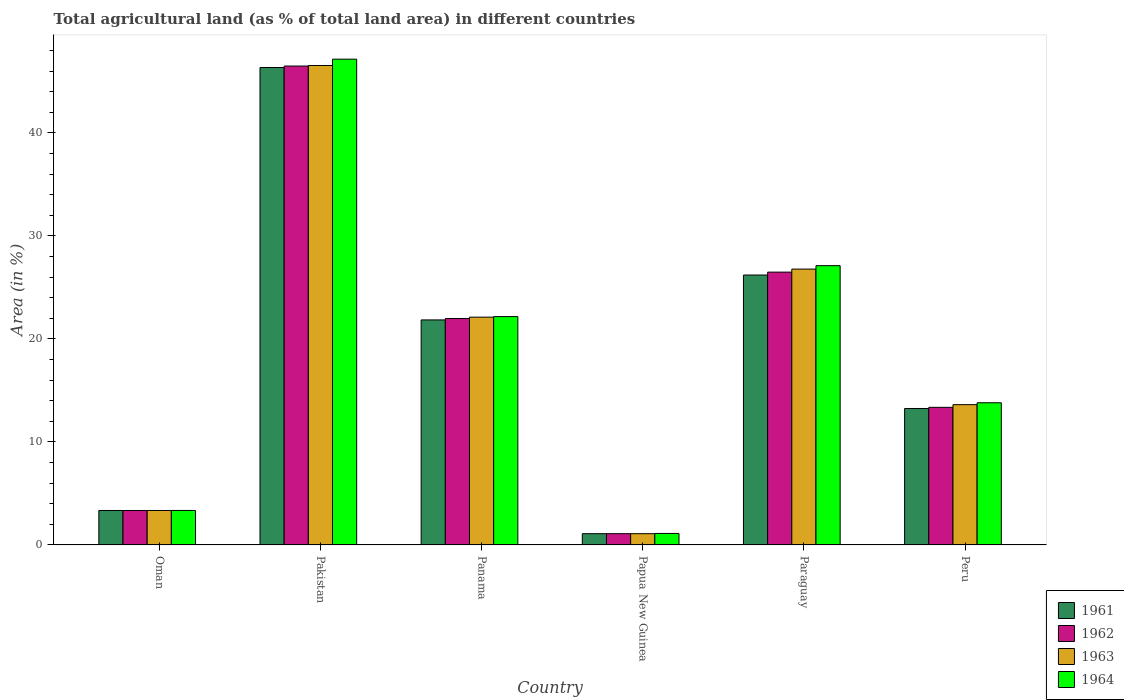How many groups of bars are there?
Offer a terse response. 6. How many bars are there on the 6th tick from the left?
Ensure brevity in your answer.  4. How many bars are there on the 2nd tick from the right?
Make the answer very short. 4. What is the label of the 2nd group of bars from the left?
Your answer should be very brief. Pakistan. In how many cases, is the number of bars for a given country not equal to the number of legend labels?
Your answer should be very brief. 0. What is the percentage of agricultural land in 1961 in Pakistan?
Your answer should be compact. 46.35. Across all countries, what is the maximum percentage of agricultural land in 1963?
Ensure brevity in your answer.  46.54. Across all countries, what is the minimum percentage of agricultural land in 1962?
Offer a very short reply. 1.09. In which country was the percentage of agricultural land in 1962 maximum?
Provide a short and direct response. Pakistan. In which country was the percentage of agricultural land in 1961 minimum?
Give a very brief answer. Papua New Guinea. What is the total percentage of agricultural land in 1961 in the graph?
Give a very brief answer. 112.08. What is the difference between the percentage of agricultural land in 1963 in Oman and that in Paraguay?
Ensure brevity in your answer.  -23.44. What is the difference between the percentage of agricultural land in 1961 in Peru and the percentage of agricultural land in 1962 in Paraguay?
Offer a terse response. -13.24. What is the average percentage of agricultural land in 1962 per country?
Keep it short and to the point. 18.79. What is the difference between the percentage of agricultural land of/in 1963 and percentage of agricultural land of/in 1962 in Oman?
Your answer should be compact. 0. In how many countries, is the percentage of agricultural land in 1963 greater than 30 %?
Your response must be concise. 1. What is the ratio of the percentage of agricultural land in 1961 in Pakistan to that in Paraguay?
Provide a succinct answer. 1.77. What is the difference between the highest and the second highest percentage of agricultural land in 1962?
Your answer should be very brief. 4.5. What is the difference between the highest and the lowest percentage of agricultural land in 1962?
Provide a succinct answer. 45.4. Is it the case that in every country, the sum of the percentage of agricultural land in 1963 and percentage of agricultural land in 1961 is greater than the sum of percentage of agricultural land in 1962 and percentage of agricultural land in 1964?
Provide a short and direct response. No. What does the 3rd bar from the right in Paraguay represents?
Ensure brevity in your answer.  1962. Is it the case that in every country, the sum of the percentage of agricultural land in 1963 and percentage of agricultural land in 1961 is greater than the percentage of agricultural land in 1962?
Your answer should be compact. Yes. How many bars are there?
Offer a very short reply. 24. Are the values on the major ticks of Y-axis written in scientific E-notation?
Your response must be concise. No. Does the graph contain grids?
Keep it short and to the point. No. What is the title of the graph?
Give a very brief answer. Total agricultural land (as % of total land area) in different countries. What is the label or title of the X-axis?
Ensure brevity in your answer.  Country. What is the label or title of the Y-axis?
Your answer should be compact. Area (in %). What is the Area (in %) in 1961 in Oman?
Keep it short and to the point. 3.34. What is the Area (in %) of 1962 in Oman?
Ensure brevity in your answer.  3.34. What is the Area (in %) of 1963 in Oman?
Your answer should be very brief. 3.34. What is the Area (in %) of 1964 in Oman?
Offer a terse response. 3.35. What is the Area (in %) of 1961 in Pakistan?
Give a very brief answer. 46.35. What is the Area (in %) in 1962 in Pakistan?
Give a very brief answer. 46.49. What is the Area (in %) in 1963 in Pakistan?
Your response must be concise. 46.54. What is the Area (in %) in 1964 in Pakistan?
Ensure brevity in your answer.  47.16. What is the Area (in %) of 1961 in Panama?
Your answer should be very brief. 21.85. What is the Area (in %) in 1962 in Panama?
Offer a terse response. 21.98. What is the Area (in %) in 1963 in Panama?
Your answer should be very brief. 22.11. What is the Area (in %) in 1964 in Panama?
Ensure brevity in your answer.  22.17. What is the Area (in %) in 1961 in Papua New Guinea?
Your response must be concise. 1.09. What is the Area (in %) of 1962 in Papua New Guinea?
Provide a succinct answer. 1.09. What is the Area (in %) in 1963 in Papua New Guinea?
Provide a succinct answer. 1.09. What is the Area (in %) in 1964 in Papua New Guinea?
Your response must be concise. 1.12. What is the Area (in %) in 1961 in Paraguay?
Offer a very short reply. 26.2. What is the Area (in %) in 1962 in Paraguay?
Give a very brief answer. 26.48. What is the Area (in %) of 1963 in Paraguay?
Provide a short and direct response. 26.78. What is the Area (in %) of 1964 in Paraguay?
Ensure brevity in your answer.  27.11. What is the Area (in %) of 1961 in Peru?
Your answer should be compact. 13.25. What is the Area (in %) in 1962 in Peru?
Keep it short and to the point. 13.36. What is the Area (in %) in 1963 in Peru?
Your answer should be very brief. 13.62. What is the Area (in %) of 1964 in Peru?
Offer a very short reply. 13.8. Across all countries, what is the maximum Area (in %) of 1961?
Provide a short and direct response. 46.35. Across all countries, what is the maximum Area (in %) of 1962?
Your response must be concise. 46.49. Across all countries, what is the maximum Area (in %) in 1963?
Your answer should be very brief. 46.54. Across all countries, what is the maximum Area (in %) of 1964?
Provide a short and direct response. 47.16. Across all countries, what is the minimum Area (in %) in 1961?
Ensure brevity in your answer.  1.09. Across all countries, what is the minimum Area (in %) in 1962?
Provide a succinct answer. 1.09. Across all countries, what is the minimum Area (in %) in 1963?
Your answer should be compact. 1.09. Across all countries, what is the minimum Area (in %) of 1964?
Offer a terse response. 1.12. What is the total Area (in %) in 1961 in the graph?
Offer a very short reply. 112.08. What is the total Area (in %) in 1962 in the graph?
Offer a terse response. 112.75. What is the total Area (in %) of 1963 in the graph?
Provide a short and direct response. 113.49. What is the total Area (in %) in 1964 in the graph?
Offer a very short reply. 114.71. What is the difference between the Area (in %) in 1961 in Oman and that in Pakistan?
Offer a terse response. -43.01. What is the difference between the Area (in %) of 1962 in Oman and that in Pakistan?
Your response must be concise. -43.15. What is the difference between the Area (in %) in 1963 in Oman and that in Pakistan?
Ensure brevity in your answer.  -43.2. What is the difference between the Area (in %) of 1964 in Oman and that in Pakistan?
Offer a terse response. -43.81. What is the difference between the Area (in %) of 1961 in Oman and that in Panama?
Keep it short and to the point. -18.5. What is the difference between the Area (in %) of 1962 in Oman and that in Panama?
Give a very brief answer. -18.64. What is the difference between the Area (in %) in 1963 in Oman and that in Panama?
Make the answer very short. -18.77. What is the difference between the Area (in %) in 1964 in Oman and that in Panama?
Offer a very short reply. -18.82. What is the difference between the Area (in %) of 1961 in Oman and that in Papua New Guinea?
Make the answer very short. 2.25. What is the difference between the Area (in %) in 1962 in Oman and that in Papua New Guinea?
Provide a succinct answer. 2.25. What is the difference between the Area (in %) of 1963 in Oman and that in Papua New Guinea?
Ensure brevity in your answer.  2.25. What is the difference between the Area (in %) of 1964 in Oman and that in Papua New Guinea?
Provide a succinct answer. 2.23. What is the difference between the Area (in %) of 1961 in Oman and that in Paraguay?
Keep it short and to the point. -22.86. What is the difference between the Area (in %) of 1962 in Oman and that in Paraguay?
Your answer should be compact. -23.14. What is the difference between the Area (in %) in 1963 in Oman and that in Paraguay?
Provide a short and direct response. -23.44. What is the difference between the Area (in %) in 1964 in Oman and that in Paraguay?
Offer a very short reply. -23.77. What is the difference between the Area (in %) of 1961 in Oman and that in Peru?
Your answer should be very brief. -9.9. What is the difference between the Area (in %) of 1962 in Oman and that in Peru?
Give a very brief answer. -10.01. What is the difference between the Area (in %) of 1963 in Oman and that in Peru?
Provide a succinct answer. -10.27. What is the difference between the Area (in %) of 1964 in Oman and that in Peru?
Give a very brief answer. -10.46. What is the difference between the Area (in %) in 1961 in Pakistan and that in Panama?
Ensure brevity in your answer.  24.5. What is the difference between the Area (in %) in 1962 in Pakistan and that in Panama?
Give a very brief answer. 24.51. What is the difference between the Area (in %) in 1963 in Pakistan and that in Panama?
Keep it short and to the point. 24.43. What is the difference between the Area (in %) of 1964 in Pakistan and that in Panama?
Your answer should be compact. 24.99. What is the difference between the Area (in %) in 1961 in Pakistan and that in Papua New Guinea?
Give a very brief answer. 45.26. What is the difference between the Area (in %) of 1962 in Pakistan and that in Papua New Guinea?
Ensure brevity in your answer.  45.4. What is the difference between the Area (in %) of 1963 in Pakistan and that in Papua New Guinea?
Your response must be concise. 45.45. What is the difference between the Area (in %) of 1964 in Pakistan and that in Papua New Guinea?
Your response must be concise. 46.05. What is the difference between the Area (in %) of 1961 in Pakistan and that in Paraguay?
Your answer should be very brief. 20.15. What is the difference between the Area (in %) in 1962 in Pakistan and that in Paraguay?
Provide a succinct answer. 20.01. What is the difference between the Area (in %) of 1963 in Pakistan and that in Paraguay?
Provide a succinct answer. 19.76. What is the difference between the Area (in %) of 1964 in Pakistan and that in Paraguay?
Provide a succinct answer. 20.05. What is the difference between the Area (in %) of 1961 in Pakistan and that in Peru?
Provide a succinct answer. 33.1. What is the difference between the Area (in %) of 1962 in Pakistan and that in Peru?
Give a very brief answer. 33.13. What is the difference between the Area (in %) in 1963 in Pakistan and that in Peru?
Your answer should be very brief. 32.93. What is the difference between the Area (in %) in 1964 in Pakistan and that in Peru?
Your answer should be very brief. 33.36. What is the difference between the Area (in %) of 1961 in Panama and that in Papua New Guinea?
Provide a succinct answer. 20.75. What is the difference between the Area (in %) in 1962 in Panama and that in Papua New Guinea?
Ensure brevity in your answer.  20.89. What is the difference between the Area (in %) of 1963 in Panama and that in Papua New Guinea?
Your answer should be compact. 21.02. What is the difference between the Area (in %) of 1964 in Panama and that in Papua New Guinea?
Give a very brief answer. 21.05. What is the difference between the Area (in %) in 1961 in Panama and that in Paraguay?
Ensure brevity in your answer.  -4.36. What is the difference between the Area (in %) in 1962 in Panama and that in Paraguay?
Make the answer very short. -4.5. What is the difference between the Area (in %) of 1963 in Panama and that in Paraguay?
Make the answer very short. -4.67. What is the difference between the Area (in %) of 1964 in Panama and that in Paraguay?
Provide a short and direct response. -4.94. What is the difference between the Area (in %) of 1961 in Panama and that in Peru?
Keep it short and to the point. 8.6. What is the difference between the Area (in %) of 1962 in Panama and that in Peru?
Ensure brevity in your answer.  8.62. What is the difference between the Area (in %) in 1963 in Panama and that in Peru?
Keep it short and to the point. 8.5. What is the difference between the Area (in %) of 1964 in Panama and that in Peru?
Your answer should be very brief. 8.37. What is the difference between the Area (in %) of 1961 in Papua New Guinea and that in Paraguay?
Keep it short and to the point. -25.11. What is the difference between the Area (in %) of 1962 in Papua New Guinea and that in Paraguay?
Ensure brevity in your answer.  -25.39. What is the difference between the Area (in %) in 1963 in Papua New Guinea and that in Paraguay?
Ensure brevity in your answer.  -25.69. What is the difference between the Area (in %) of 1964 in Papua New Guinea and that in Paraguay?
Provide a short and direct response. -26. What is the difference between the Area (in %) of 1961 in Papua New Guinea and that in Peru?
Ensure brevity in your answer.  -12.15. What is the difference between the Area (in %) in 1962 in Papua New Guinea and that in Peru?
Your answer should be very brief. -12.27. What is the difference between the Area (in %) of 1963 in Papua New Guinea and that in Peru?
Provide a succinct answer. -12.52. What is the difference between the Area (in %) in 1964 in Papua New Guinea and that in Peru?
Offer a terse response. -12.69. What is the difference between the Area (in %) in 1961 in Paraguay and that in Peru?
Keep it short and to the point. 12.96. What is the difference between the Area (in %) of 1962 in Paraguay and that in Peru?
Provide a succinct answer. 13.13. What is the difference between the Area (in %) in 1963 in Paraguay and that in Peru?
Offer a terse response. 13.16. What is the difference between the Area (in %) of 1964 in Paraguay and that in Peru?
Your answer should be compact. 13.31. What is the difference between the Area (in %) of 1961 in Oman and the Area (in %) of 1962 in Pakistan?
Keep it short and to the point. -43.15. What is the difference between the Area (in %) in 1961 in Oman and the Area (in %) in 1963 in Pakistan?
Keep it short and to the point. -43.2. What is the difference between the Area (in %) of 1961 in Oman and the Area (in %) of 1964 in Pakistan?
Provide a succinct answer. -43.82. What is the difference between the Area (in %) of 1962 in Oman and the Area (in %) of 1963 in Pakistan?
Offer a terse response. -43.2. What is the difference between the Area (in %) in 1962 in Oman and the Area (in %) in 1964 in Pakistan?
Ensure brevity in your answer.  -43.82. What is the difference between the Area (in %) of 1963 in Oman and the Area (in %) of 1964 in Pakistan?
Your answer should be compact. -43.82. What is the difference between the Area (in %) of 1961 in Oman and the Area (in %) of 1962 in Panama?
Offer a terse response. -18.64. What is the difference between the Area (in %) in 1961 in Oman and the Area (in %) in 1963 in Panama?
Your answer should be compact. -18.77. What is the difference between the Area (in %) of 1961 in Oman and the Area (in %) of 1964 in Panama?
Your answer should be compact. -18.82. What is the difference between the Area (in %) of 1962 in Oman and the Area (in %) of 1963 in Panama?
Provide a short and direct response. -18.77. What is the difference between the Area (in %) in 1962 in Oman and the Area (in %) in 1964 in Panama?
Make the answer very short. -18.82. What is the difference between the Area (in %) of 1963 in Oman and the Area (in %) of 1964 in Panama?
Give a very brief answer. -18.82. What is the difference between the Area (in %) of 1961 in Oman and the Area (in %) of 1962 in Papua New Guinea?
Offer a very short reply. 2.25. What is the difference between the Area (in %) of 1961 in Oman and the Area (in %) of 1963 in Papua New Guinea?
Offer a terse response. 2.25. What is the difference between the Area (in %) of 1961 in Oman and the Area (in %) of 1964 in Papua New Guinea?
Your answer should be compact. 2.23. What is the difference between the Area (in %) in 1962 in Oman and the Area (in %) in 1963 in Papua New Guinea?
Make the answer very short. 2.25. What is the difference between the Area (in %) of 1962 in Oman and the Area (in %) of 1964 in Papua New Guinea?
Provide a succinct answer. 2.23. What is the difference between the Area (in %) of 1963 in Oman and the Area (in %) of 1964 in Papua New Guinea?
Ensure brevity in your answer.  2.23. What is the difference between the Area (in %) in 1961 in Oman and the Area (in %) in 1962 in Paraguay?
Your answer should be very brief. -23.14. What is the difference between the Area (in %) in 1961 in Oman and the Area (in %) in 1963 in Paraguay?
Ensure brevity in your answer.  -23.44. What is the difference between the Area (in %) of 1961 in Oman and the Area (in %) of 1964 in Paraguay?
Offer a terse response. -23.77. What is the difference between the Area (in %) of 1962 in Oman and the Area (in %) of 1963 in Paraguay?
Provide a succinct answer. -23.44. What is the difference between the Area (in %) of 1962 in Oman and the Area (in %) of 1964 in Paraguay?
Provide a succinct answer. -23.77. What is the difference between the Area (in %) in 1963 in Oman and the Area (in %) in 1964 in Paraguay?
Your answer should be very brief. -23.77. What is the difference between the Area (in %) of 1961 in Oman and the Area (in %) of 1962 in Peru?
Offer a terse response. -10.01. What is the difference between the Area (in %) in 1961 in Oman and the Area (in %) in 1963 in Peru?
Offer a very short reply. -10.27. What is the difference between the Area (in %) of 1961 in Oman and the Area (in %) of 1964 in Peru?
Make the answer very short. -10.46. What is the difference between the Area (in %) in 1962 in Oman and the Area (in %) in 1963 in Peru?
Ensure brevity in your answer.  -10.27. What is the difference between the Area (in %) in 1962 in Oman and the Area (in %) in 1964 in Peru?
Ensure brevity in your answer.  -10.46. What is the difference between the Area (in %) in 1963 in Oman and the Area (in %) in 1964 in Peru?
Provide a succinct answer. -10.46. What is the difference between the Area (in %) in 1961 in Pakistan and the Area (in %) in 1962 in Panama?
Make the answer very short. 24.37. What is the difference between the Area (in %) of 1961 in Pakistan and the Area (in %) of 1963 in Panama?
Your response must be concise. 24.23. What is the difference between the Area (in %) of 1961 in Pakistan and the Area (in %) of 1964 in Panama?
Offer a very short reply. 24.18. What is the difference between the Area (in %) of 1962 in Pakistan and the Area (in %) of 1963 in Panama?
Make the answer very short. 24.38. What is the difference between the Area (in %) of 1962 in Pakistan and the Area (in %) of 1964 in Panama?
Make the answer very short. 24.32. What is the difference between the Area (in %) of 1963 in Pakistan and the Area (in %) of 1964 in Panama?
Provide a succinct answer. 24.38. What is the difference between the Area (in %) in 1961 in Pakistan and the Area (in %) in 1962 in Papua New Guinea?
Offer a terse response. 45.26. What is the difference between the Area (in %) in 1961 in Pakistan and the Area (in %) in 1963 in Papua New Guinea?
Provide a succinct answer. 45.26. What is the difference between the Area (in %) of 1961 in Pakistan and the Area (in %) of 1964 in Papua New Guinea?
Your response must be concise. 45.23. What is the difference between the Area (in %) of 1962 in Pakistan and the Area (in %) of 1963 in Papua New Guinea?
Offer a very short reply. 45.4. What is the difference between the Area (in %) in 1962 in Pakistan and the Area (in %) in 1964 in Papua New Guinea?
Provide a succinct answer. 45.38. What is the difference between the Area (in %) of 1963 in Pakistan and the Area (in %) of 1964 in Papua New Guinea?
Your response must be concise. 45.43. What is the difference between the Area (in %) of 1961 in Pakistan and the Area (in %) of 1962 in Paraguay?
Make the answer very short. 19.87. What is the difference between the Area (in %) in 1961 in Pakistan and the Area (in %) in 1963 in Paraguay?
Your response must be concise. 19.57. What is the difference between the Area (in %) of 1961 in Pakistan and the Area (in %) of 1964 in Paraguay?
Your response must be concise. 19.24. What is the difference between the Area (in %) in 1962 in Pakistan and the Area (in %) in 1963 in Paraguay?
Offer a very short reply. 19.71. What is the difference between the Area (in %) in 1962 in Pakistan and the Area (in %) in 1964 in Paraguay?
Your answer should be very brief. 19.38. What is the difference between the Area (in %) of 1963 in Pakistan and the Area (in %) of 1964 in Paraguay?
Make the answer very short. 19.43. What is the difference between the Area (in %) of 1961 in Pakistan and the Area (in %) of 1962 in Peru?
Provide a short and direct response. 32.99. What is the difference between the Area (in %) in 1961 in Pakistan and the Area (in %) in 1963 in Peru?
Provide a succinct answer. 32.73. What is the difference between the Area (in %) in 1961 in Pakistan and the Area (in %) in 1964 in Peru?
Give a very brief answer. 32.55. What is the difference between the Area (in %) of 1962 in Pakistan and the Area (in %) of 1963 in Peru?
Keep it short and to the point. 32.88. What is the difference between the Area (in %) of 1962 in Pakistan and the Area (in %) of 1964 in Peru?
Provide a short and direct response. 32.69. What is the difference between the Area (in %) of 1963 in Pakistan and the Area (in %) of 1964 in Peru?
Ensure brevity in your answer.  32.74. What is the difference between the Area (in %) of 1961 in Panama and the Area (in %) of 1962 in Papua New Guinea?
Provide a succinct answer. 20.75. What is the difference between the Area (in %) of 1961 in Panama and the Area (in %) of 1963 in Papua New Guinea?
Make the answer very short. 20.75. What is the difference between the Area (in %) in 1961 in Panama and the Area (in %) in 1964 in Papua New Guinea?
Your answer should be very brief. 20.73. What is the difference between the Area (in %) of 1962 in Panama and the Area (in %) of 1963 in Papua New Guinea?
Keep it short and to the point. 20.89. What is the difference between the Area (in %) of 1962 in Panama and the Area (in %) of 1964 in Papua New Guinea?
Offer a very short reply. 20.86. What is the difference between the Area (in %) in 1963 in Panama and the Area (in %) in 1964 in Papua New Guinea?
Keep it short and to the point. 21. What is the difference between the Area (in %) of 1961 in Panama and the Area (in %) of 1962 in Paraguay?
Your answer should be compact. -4.64. What is the difference between the Area (in %) in 1961 in Panama and the Area (in %) in 1963 in Paraguay?
Make the answer very short. -4.94. What is the difference between the Area (in %) in 1961 in Panama and the Area (in %) in 1964 in Paraguay?
Provide a succinct answer. -5.27. What is the difference between the Area (in %) of 1962 in Panama and the Area (in %) of 1963 in Paraguay?
Your answer should be very brief. -4.8. What is the difference between the Area (in %) of 1962 in Panama and the Area (in %) of 1964 in Paraguay?
Provide a short and direct response. -5.13. What is the difference between the Area (in %) of 1963 in Panama and the Area (in %) of 1964 in Paraguay?
Make the answer very short. -5. What is the difference between the Area (in %) in 1961 in Panama and the Area (in %) in 1962 in Peru?
Ensure brevity in your answer.  8.49. What is the difference between the Area (in %) of 1961 in Panama and the Area (in %) of 1963 in Peru?
Offer a very short reply. 8.23. What is the difference between the Area (in %) of 1961 in Panama and the Area (in %) of 1964 in Peru?
Ensure brevity in your answer.  8.04. What is the difference between the Area (in %) in 1962 in Panama and the Area (in %) in 1963 in Peru?
Offer a terse response. 8.36. What is the difference between the Area (in %) of 1962 in Panama and the Area (in %) of 1964 in Peru?
Keep it short and to the point. 8.18. What is the difference between the Area (in %) of 1963 in Panama and the Area (in %) of 1964 in Peru?
Your answer should be very brief. 8.31. What is the difference between the Area (in %) of 1961 in Papua New Guinea and the Area (in %) of 1962 in Paraguay?
Give a very brief answer. -25.39. What is the difference between the Area (in %) of 1961 in Papua New Guinea and the Area (in %) of 1963 in Paraguay?
Provide a succinct answer. -25.69. What is the difference between the Area (in %) of 1961 in Papua New Guinea and the Area (in %) of 1964 in Paraguay?
Ensure brevity in your answer.  -26.02. What is the difference between the Area (in %) in 1962 in Papua New Guinea and the Area (in %) in 1963 in Paraguay?
Keep it short and to the point. -25.69. What is the difference between the Area (in %) in 1962 in Papua New Guinea and the Area (in %) in 1964 in Paraguay?
Your answer should be very brief. -26.02. What is the difference between the Area (in %) in 1963 in Papua New Guinea and the Area (in %) in 1964 in Paraguay?
Provide a succinct answer. -26.02. What is the difference between the Area (in %) in 1961 in Papua New Guinea and the Area (in %) in 1962 in Peru?
Your answer should be compact. -12.27. What is the difference between the Area (in %) of 1961 in Papua New Guinea and the Area (in %) of 1963 in Peru?
Your answer should be very brief. -12.52. What is the difference between the Area (in %) in 1961 in Papua New Guinea and the Area (in %) in 1964 in Peru?
Your response must be concise. -12.71. What is the difference between the Area (in %) in 1962 in Papua New Guinea and the Area (in %) in 1963 in Peru?
Make the answer very short. -12.52. What is the difference between the Area (in %) of 1962 in Papua New Guinea and the Area (in %) of 1964 in Peru?
Offer a terse response. -12.71. What is the difference between the Area (in %) of 1963 in Papua New Guinea and the Area (in %) of 1964 in Peru?
Keep it short and to the point. -12.71. What is the difference between the Area (in %) of 1961 in Paraguay and the Area (in %) of 1962 in Peru?
Ensure brevity in your answer.  12.85. What is the difference between the Area (in %) of 1961 in Paraguay and the Area (in %) of 1963 in Peru?
Ensure brevity in your answer.  12.59. What is the difference between the Area (in %) in 1961 in Paraguay and the Area (in %) in 1964 in Peru?
Offer a very short reply. 12.4. What is the difference between the Area (in %) in 1962 in Paraguay and the Area (in %) in 1963 in Peru?
Keep it short and to the point. 12.87. What is the difference between the Area (in %) of 1962 in Paraguay and the Area (in %) of 1964 in Peru?
Provide a short and direct response. 12.68. What is the difference between the Area (in %) in 1963 in Paraguay and the Area (in %) in 1964 in Peru?
Give a very brief answer. 12.98. What is the average Area (in %) of 1961 per country?
Make the answer very short. 18.68. What is the average Area (in %) in 1962 per country?
Provide a succinct answer. 18.79. What is the average Area (in %) of 1963 per country?
Keep it short and to the point. 18.92. What is the average Area (in %) of 1964 per country?
Make the answer very short. 19.12. What is the difference between the Area (in %) of 1961 and Area (in %) of 1963 in Oman?
Your answer should be very brief. 0. What is the difference between the Area (in %) in 1961 and Area (in %) in 1964 in Oman?
Your answer should be compact. -0. What is the difference between the Area (in %) of 1962 and Area (in %) of 1963 in Oman?
Ensure brevity in your answer.  0. What is the difference between the Area (in %) in 1962 and Area (in %) in 1964 in Oman?
Ensure brevity in your answer.  -0. What is the difference between the Area (in %) of 1963 and Area (in %) of 1964 in Oman?
Give a very brief answer. -0. What is the difference between the Area (in %) of 1961 and Area (in %) of 1962 in Pakistan?
Your answer should be very brief. -0.14. What is the difference between the Area (in %) of 1961 and Area (in %) of 1963 in Pakistan?
Offer a terse response. -0.19. What is the difference between the Area (in %) of 1961 and Area (in %) of 1964 in Pakistan?
Your response must be concise. -0.81. What is the difference between the Area (in %) of 1962 and Area (in %) of 1963 in Pakistan?
Make the answer very short. -0.05. What is the difference between the Area (in %) in 1962 and Area (in %) in 1964 in Pakistan?
Ensure brevity in your answer.  -0.67. What is the difference between the Area (in %) in 1963 and Area (in %) in 1964 in Pakistan?
Ensure brevity in your answer.  -0.62. What is the difference between the Area (in %) of 1961 and Area (in %) of 1962 in Panama?
Make the answer very short. -0.13. What is the difference between the Area (in %) in 1961 and Area (in %) in 1963 in Panama?
Offer a very short reply. -0.27. What is the difference between the Area (in %) in 1961 and Area (in %) in 1964 in Panama?
Make the answer very short. -0.32. What is the difference between the Area (in %) in 1962 and Area (in %) in 1963 in Panama?
Keep it short and to the point. -0.13. What is the difference between the Area (in %) in 1962 and Area (in %) in 1964 in Panama?
Ensure brevity in your answer.  -0.19. What is the difference between the Area (in %) in 1963 and Area (in %) in 1964 in Panama?
Give a very brief answer. -0.05. What is the difference between the Area (in %) in 1961 and Area (in %) in 1963 in Papua New Guinea?
Keep it short and to the point. 0. What is the difference between the Area (in %) in 1961 and Area (in %) in 1964 in Papua New Guinea?
Provide a succinct answer. -0.02. What is the difference between the Area (in %) of 1962 and Area (in %) of 1963 in Papua New Guinea?
Keep it short and to the point. 0. What is the difference between the Area (in %) of 1962 and Area (in %) of 1964 in Papua New Guinea?
Your answer should be compact. -0.02. What is the difference between the Area (in %) of 1963 and Area (in %) of 1964 in Papua New Guinea?
Make the answer very short. -0.02. What is the difference between the Area (in %) of 1961 and Area (in %) of 1962 in Paraguay?
Give a very brief answer. -0.28. What is the difference between the Area (in %) in 1961 and Area (in %) in 1963 in Paraguay?
Provide a short and direct response. -0.58. What is the difference between the Area (in %) of 1961 and Area (in %) of 1964 in Paraguay?
Make the answer very short. -0.91. What is the difference between the Area (in %) of 1962 and Area (in %) of 1963 in Paraguay?
Your answer should be compact. -0.3. What is the difference between the Area (in %) of 1962 and Area (in %) of 1964 in Paraguay?
Make the answer very short. -0.63. What is the difference between the Area (in %) of 1963 and Area (in %) of 1964 in Paraguay?
Your answer should be compact. -0.33. What is the difference between the Area (in %) of 1961 and Area (in %) of 1962 in Peru?
Keep it short and to the point. -0.11. What is the difference between the Area (in %) of 1961 and Area (in %) of 1963 in Peru?
Ensure brevity in your answer.  -0.37. What is the difference between the Area (in %) of 1961 and Area (in %) of 1964 in Peru?
Make the answer very short. -0.56. What is the difference between the Area (in %) in 1962 and Area (in %) in 1963 in Peru?
Keep it short and to the point. -0.26. What is the difference between the Area (in %) in 1962 and Area (in %) in 1964 in Peru?
Make the answer very short. -0.44. What is the difference between the Area (in %) of 1963 and Area (in %) of 1964 in Peru?
Offer a very short reply. -0.19. What is the ratio of the Area (in %) in 1961 in Oman to that in Pakistan?
Provide a short and direct response. 0.07. What is the ratio of the Area (in %) in 1962 in Oman to that in Pakistan?
Provide a short and direct response. 0.07. What is the ratio of the Area (in %) in 1963 in Oman to that in Pakistan?
Your answer should be compact. 0.07. What is the ratio of the Area (in %) in 1964 in Oman to that in Pakistan?
Provide a short and direct response. 0.07. What is the ratio of the Area (in %) of 1961 in Oman to that in Panama?
Your answer should be very brief. 0.15. What is the ratio of the Area (in %) of 1962 in Oman to that in Panama?
Offer a terse response. 0.15. What is the ratio of the Area (in %) of 1963 in Oman to that in Panama?
Ensure brevity in your answer.  0.15. What is the ratio of the Area (in %) in 1964 in Oman to that in Panama?
Keep it short and to the point. 0.15. What is the ratio of the Area (in %) in 1961 in Oman to that in Papua New Guinea?
Your answer should be compact. 3.06. What is the ratio of the Area (in %) of 1962 in Oman to that in Papua New Guinea?
Your answer should be very brief. 3.06. What is the ratio of the Area (in %) in 1963 in Oman to that in Papua New Guinea?
Offer a very short reply. 3.06. What is the ratio of the Area (in %) of 1964 in Oman to that in Papua New Guinea?
Keep it short and to the point. 3. What is the ratio of the Area (in %) of 1961 in Oman to that in Paraguay?
Give a very brief answer. 0.13. What is the ratio of the Area (in %) of 1962 in Oman to that in Paraguay?
Provide a succinct answer. 0.13. What is the ratio of the Area (in %) in 1963 in Oman to that in Paraguay?
Make the answer very short. 0.12. What is the ratio of the Area (in %) in 1964 in Oman to that in Paraguay?
Keep it short and to the point. 0.12. What is the ratio of the Area (in %) in 1961 in Oman to that in Peru?
Your response must be concise. 0.25. What is the ratio of the Area (in %) of 1962 in Oman to that in Peru?
Your response must be concise. 0.25. What is the ratio of the Area (in %) in 1963 in Oman to that in Peru?
Keep it short and to the point. 0.25. What is the ratio of the Area (in %) of 1964 in Oman to that in Peru?
Offer a very short reply. 0.24. What is the ratio of the Area (in %) in 1961 in Pakistan to that in Panama?
Make the answer very short. 2.12. What is the ratio of the Area (in %) of 1962 in Pakistan to that in Panama?
Offer a very short reply. 2.12. What is the ratio of the Area (in %) in 1963 in Pakistan to that in Panama?
Keep it short and to the point. 2.1. What is the ratio of the Area (in %) of 1964 in Pakistan to that in Panama?
Provide a short and direct response. 2.13. What is the ratio of the Area (in %) of 1961 in Pakistan to that in Papua New Guinea?
Your answer should be very brief. 42.4. What is the ratio of the Area (in %) of 1962 in Pakistan to that in Papua New Guinea?
Ensure brevity in your answer.  42.53. What is the ratio of the Area (in %) in 1963 in Pakistan to that in Papua New Guinea?
Give a very brief answer. 42.58. What is the ratio of the Area (in %) in 1964 in Pakistan to that in Papua New Guinea?
Your answer should be compact. 42.29. What is the ratio of the Area (in %) of 1961 in Pakistan to that in Paraguay?
Keep it short and to the point. 1.77. What is the ratio of the Area (in %) of 1962 in Pakistan to that in Paraguay?
Ensure brevity in your answer.  1.76. What is the ratio of the Area (in %) of 1963 in Pakistan to that in Paraguay?
Ensure brevity in your answer.  1.74. What is the ratio of the Area (in %) in 1964 in Pakistan to that in Paraguay?
Give a very brief answer. 1.74. What is the ratio of the Area (in %) in 1961 in Pakistan to that in Peru?
Your answer should be compact. 3.5. What is the ratio of the Area (in %) of 1962 in Pakistan to that in Peru?
Your answer should be very brief. 3.48. What is the ratio of the Area (in %) in 1963 in Pakistan to that in Peru?
Your response must be concise. 3.42. What is the ratio of the Area (in %) in 1964 in Pakistan to that in Peru?
Provide a succinct answer. 3.42. What is the ratio of the Area (in %) of 1961 in Panama to that in Papua New Guinea?
Provide a succinct answer. 19.99. What is the ratio of the Area (in %) of 1962 in Panama to that in Papua New Guinea?
Make the answer very short. 20.11. What is the ratio of the Area (in %) of 1963 in Panama to that in Papua New Guinea?
Keep it short and to the point. 20.23. What is the ratio of the Area (in %) in 1964 in Panama to that in Papua New Guinea?
Provide a short and direct response. 19.88. What is the ratio of the Area (in %) in 1961 in Panama to that in Paraguay?
Ensure brevity in your answer.  0.83. What is the ratio of the Area (in %) of 1962 in Panama to that in Paraguay?
Ensure brevity in your answer.  0.83. What is the ratio of the Area (in %) of 1963 in Panama to that in Paraguay?
Keep it short and to the point. 0.83. What is the ratio of the Area (in %) in 1964 in Panama to that in Paraguay?
Offer a terse response. 0.82. What is the ratio of the Area (in %) in 1961 in Panama to that in Peru?
Provide a succinct answer. 1.65. What is the ratio of the Area (in %) of 1962 in Panama to that in Peru?
Give a very brief answer. 1.65. What is the ratio of the Area (in %) in 1963 in Panama to that in Peru?
Keep it short and to the point. 1.62. What is the ratio of the Area (in %) in 1964 in Panama to that in Peru?
Your response must be concise. 1.61. What is the ratio of the Area (in %) in 1961 in Papua New Guinea to that in Paraguay?
Provide a succinct answer. 0.04. What is the ratio of the Area (in %) of 1962 in Papua New Guinea to that in Paraguay?
Your answer should be very brief. 0.04. What is the ratio of the Area (in %) in 1963 in Papua New Guinea to that in Paraguay?
Provide a short and direct response. 0.04. What is the ratio of the Area (in %) of 1964 in Papua New Guinea to that in Paraguay?
Your response must be concise. 0.04. What is the ratio of the Area (in %) of 1961 in Papua New Guinea to that in Peru?
Your response must be concise. 0.08. What is the ratio of the Area (in %) of 1962 in Papua New Guinea to that in Peru?
Give a very brief answer. 0.08. What is the ratio of the Area (in %) of 1963 in Papua New Guinea to that in Peru?
Ensure brevity in your answer.  0.08. What is the ratio of the Area (in %) of 1964 in Papua New Guinea to that in Peru?
Provide a succinct answer. 0.08. What is the ratio of the Area (in %) in 1961 in Paraguay to that in Peru?
Offer a very short reply. 1.98. What is the ratio of the Area (in %) of 1962 in Paraguay to that in Peru?
Offer a terse response. 1.98. What is the ratio of the Area (in %) of 1963 in Paraguay to that in Peru?
Provide a succinct answer. 1.97. What is the ratio of the Area (in %) of 1964 in Paraguay to that in Peru?
Offer a very short reply. 1.96. What is the difference between the highest and the second highest Area (in %) in 1961?
Ensure brevity in your answer.  20.15. What is the difference between the highest and the second highest Area (in %) of 1962?
Your answer should be very brief. 20.01. What is the difference between the highest and the second highest Area (in %) of 1963?
Offer a very short reply. 19.76. What is the difference between the highest and the second highest Area (in %) in 1964?
Your answer should be compact. 20.05. What is the difference between the highest and the lowest Area (in %) of 1961?
Ensure brevity in your answer.  45.26. What is the difference between the highest and the lowest Area (in %) in 1962?
Provide a short and direct response. 45.4. What is the difference between the highest and the lowest Area (in %) of 1963?
Give a very brief answer. 45.45. What is the difference between the highest and the lowest Area (in %) in 1964?
Provide a succinct answer. 46.05. 